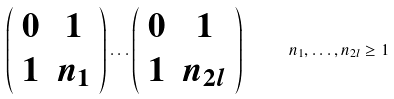<formula> <loc_0><loc_0><loc_500><loc_500>\left ( \begin{array} { c c } 0 & 1 \\ 1 & n _ { 1 } \\ \end{array} \right ) \dots \left ( \begin{array} { c c } 0 & 1 \\ 1 & n _ { 2 l } \\ \end{array} \right ) \quad \ n _ { 1 } , \dots , n _ { 2 l } \geq 1</formula> 